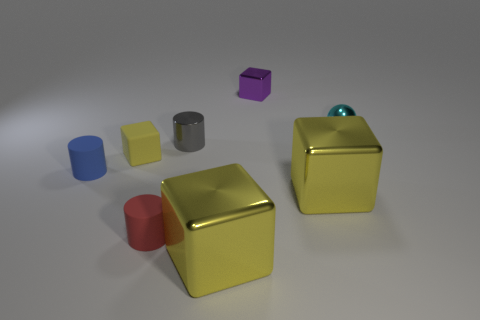How big is the metal block that is both behind the small red thing and in front of the blue matte cylinder?
Offer a very short reply. Large. How many large purple matte spheres are there?
Ensure brevity in your answer.  0. Are there fewer red matte cylinders than blue metal cylinders?
Give a very brief answer. No. There is a yellow block that is the same size as the gray cylinder; what is it made of?
Make the answer very short. Rubber. What number of things are either red matte objects or tiny metal cylinders?
Offer a very short reply. 2. What number of small objects are both behind the blue rubber cylinder and to the left of the red cylinder?
Provide a short and direct response. 1. Are there fewer small purple metal blocks left of the yellow matte thing than big yellow balls?
Provide a short and direct response. No. There is a yellow object that is the same size as the blue thing; what shape is it?
Your response must be concise. Cube. How many other things are the same color as the rubber cube?
Ensure brevity in your answer.  2. Does the yellow rubber thing have the same size as the cyan sphere?
Offer a very short reply. Yes. 